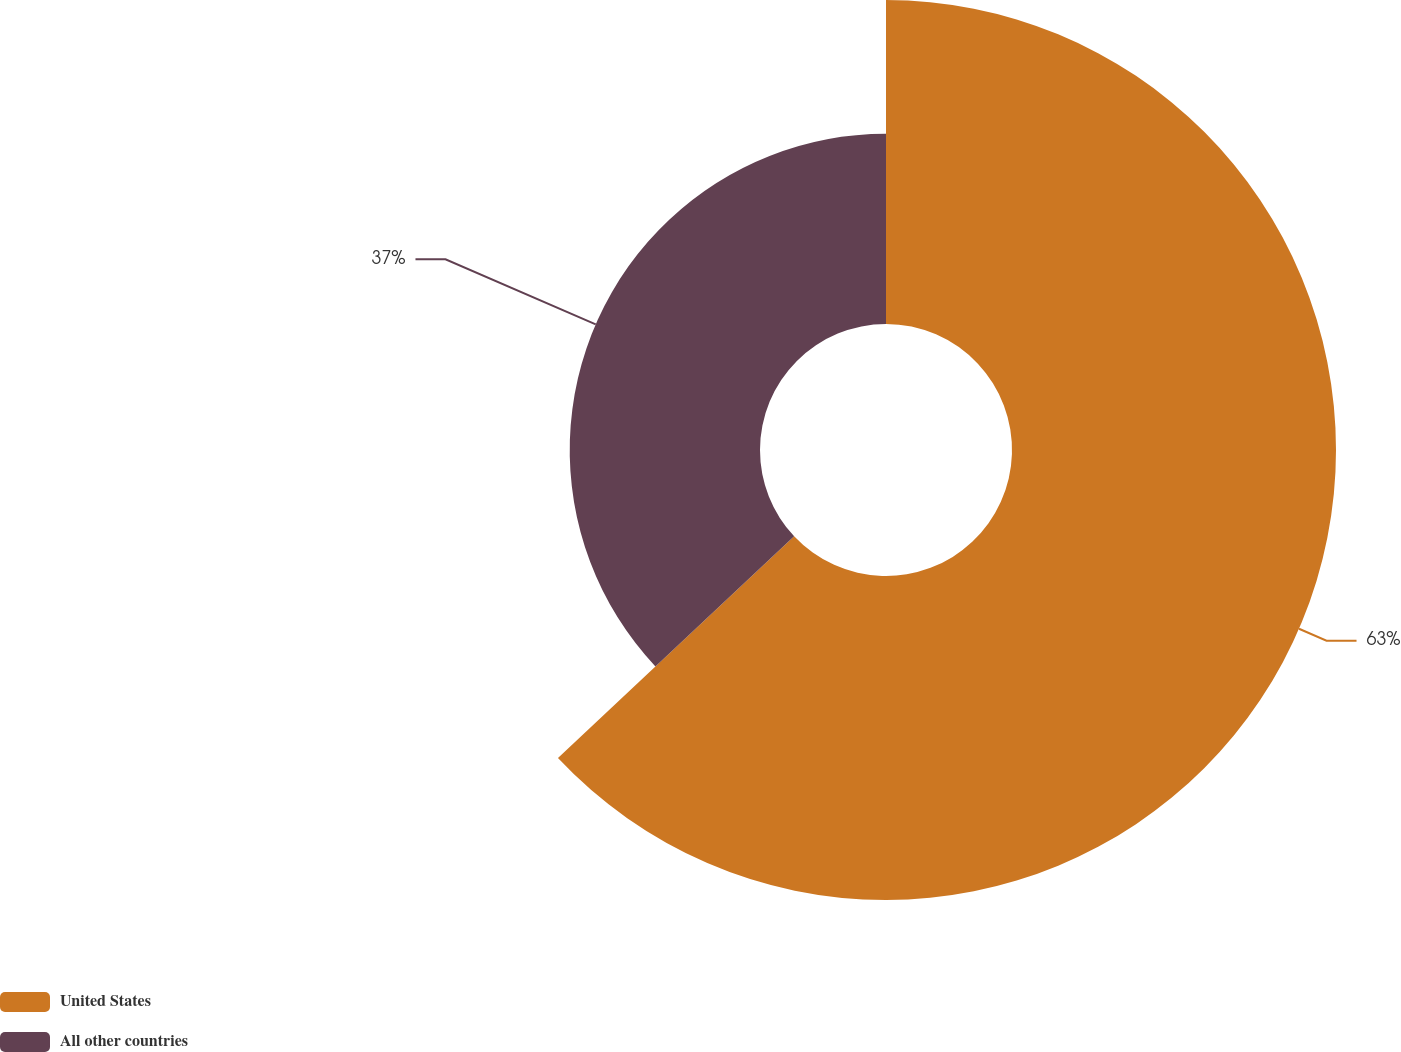<chart> <loc_0><loc_0><loc_500><loc_500><pie_chart><fcel>United States<fcel>All other countries<nl><fcel>63.0%<fcel>37.0%<nl></chart> 